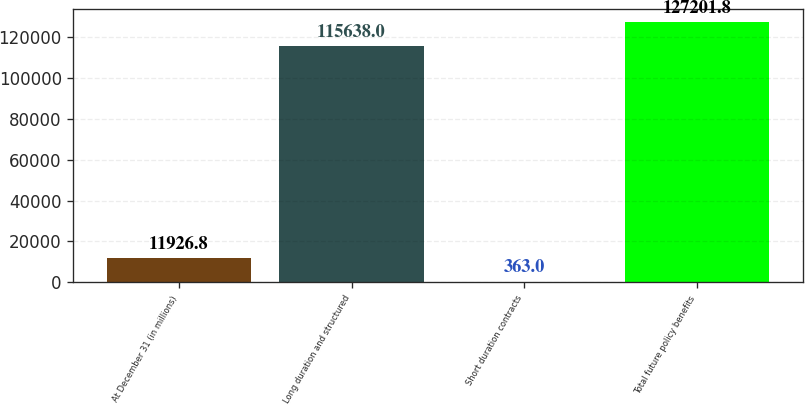Convert chart. <chart><loc_0><loc_0><loc_500><loc_500><bar_chart><fcel>At December 31 (in millions)<fcel>Long duration and structured<fcel>Short duration contracts<fcel>Total future policy benefits<nl><fcel>11926.8<fcel>115638<fcel>363<fcel>127202<nl></chart> 